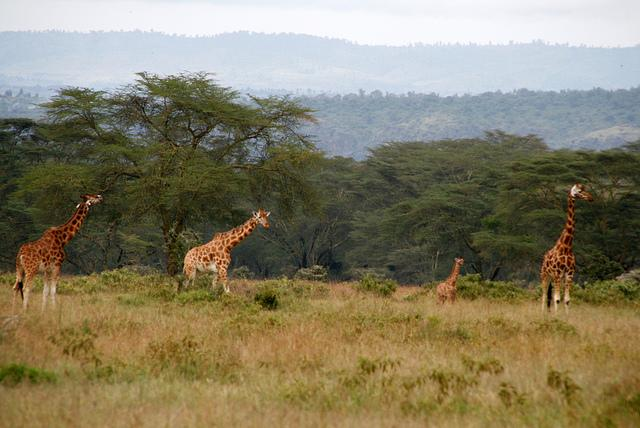What direction are the giraffes looking? right 